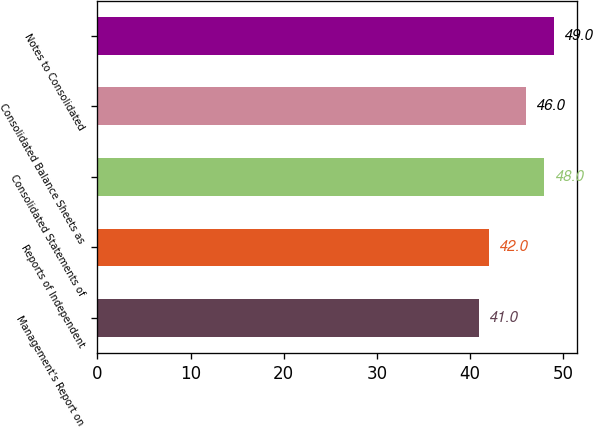<chart> <loc_0><loc_0><loc_500><loc_500><bar_chart><fcel>Management's Report on<fcel>Reports of Independent<fcel>Consolidated Statements of<fcel>Consolidated Balance Sheets as<fcel>Notes to Consolidated<nl><fcel>41<fcel>42<fcel>48<fcel>46<fcel>49<nl></chart> 